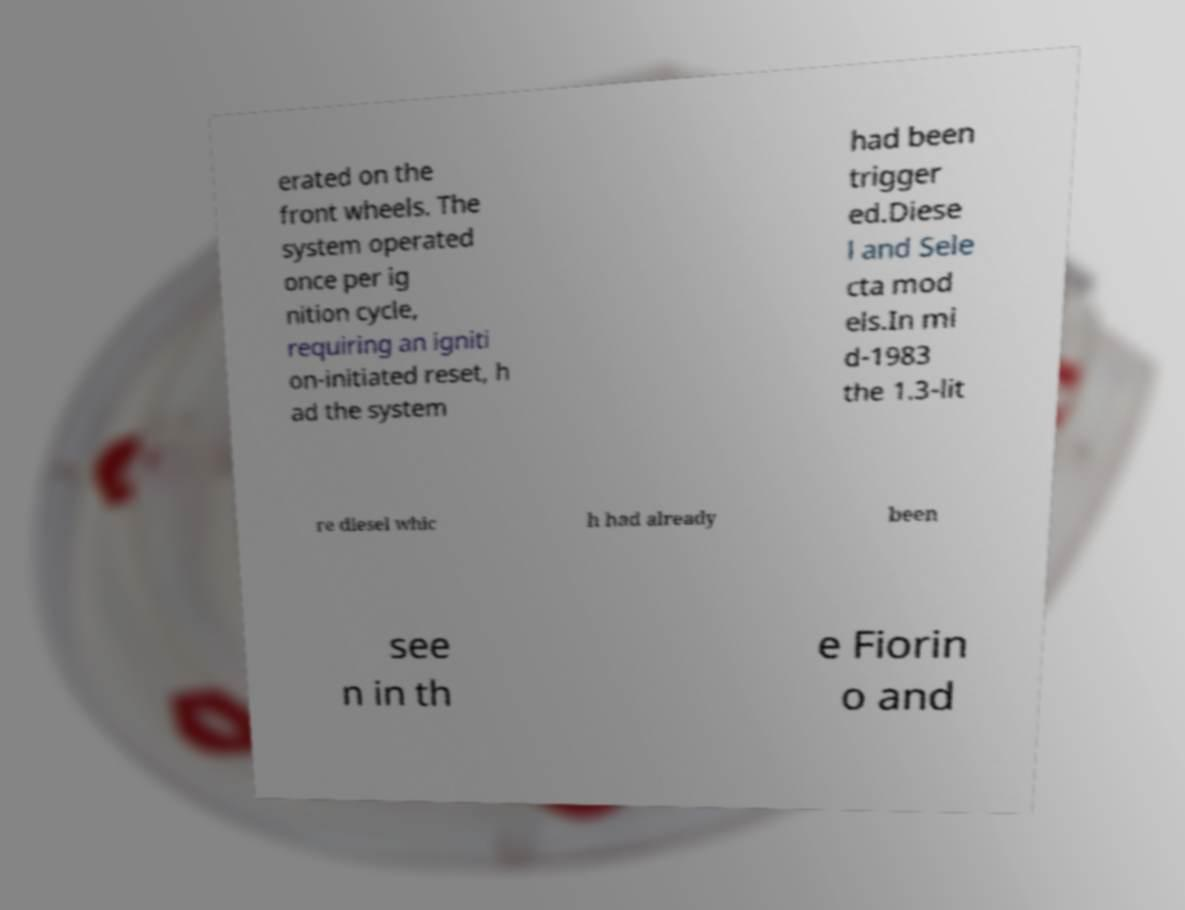What messages or text are displayed in this image? I need them in a readable, typed format. erated on the front wheels. The system operated once per ig nition cycle, requiring an igniti on-initiated reset, h ad the system had been trigger ed.Diese l and Sele cta mod els.In mi d-1983 the 1.3-lit re diesel whic h had already been see n in th e Fiorin o and 